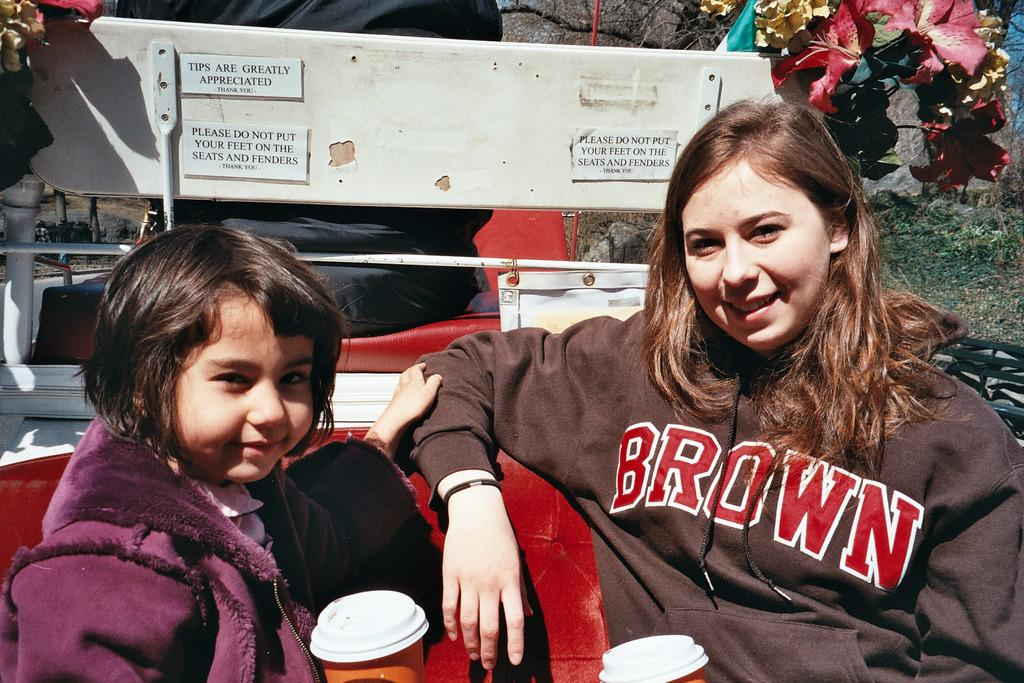<image>
Render a clear and concise summary of the photo. Two people are riding on the back of a vehicle, with her shirt saying BROWN and the sign saying TIPS ARE GREATLY APPRECIATED THANK YOU. 